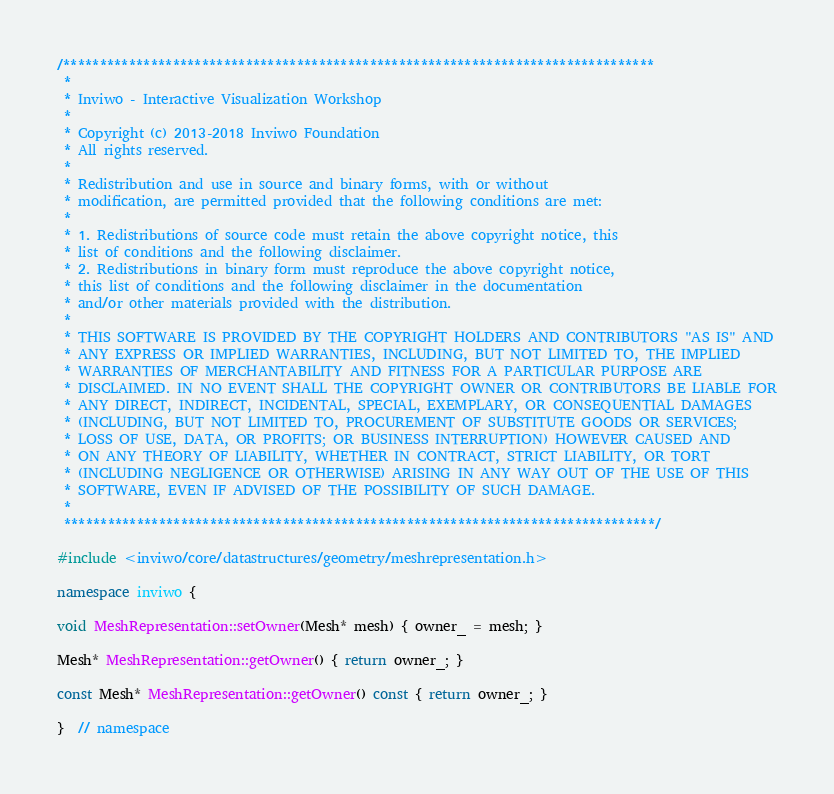<code> <loc_0><loc_0><loc_500><loc_500><_C++_>/*********************************************************************************
 *
 * Inviwo - Interactive Visualization Workshop
 *
 * Copyright (c) 2013-2018 Inviwo Foundation
 * All rights reserved.
 *
 * Redistribution and use in source and binary forms, with or without
 * modification, are permitted provided that the following conditions are met:
 *
 * 1. Redistributions of source code must retain the above copyright notice, this
 * list of conditions and the following disclaimer.
 * 2. Redistributions in binary form must reproduce the above copyright notice,
 * this list of conditions and the following disclaimer in the documentation
 * and/or other materials provided with the distribution.
 *
 * THIS SOFTWARE IS PROVIDED BY THE COPYRIGHT HOLDERS AND CONTRIBUTORS "AS IS" AND
 * ANY EXPRESS OR IMPLIED WARRANTIES, INCLUDING, BUT NOT LIMITED TO, THE IMPLIED
 * WARRANTIES OF MERCHANTABILITY AND FITNESS FOR A PARTICULAR PURPOSE ARE
 * DISCLAIMED. IN NO EVENT SHALL THE COPYRIGHT OWNER OR CONTRIBUTORS BE LIABLE FOR
 * ANY DIRECT, INDIRECT, INCIDENTAL, SPECIAL, EXEMPLARY, OR CONSEQUENTIAL DAMAGES
 * (INCLUDING, BUT NOT LIMITED TO, PROCUREMENT OF SUBSTITUTE GOODS OR SERVICES;
 * LOSS OF USE, DATA, OR PROFITS; OR BUSINESS INTERRUPTION) HOWEVER CAUSED AND
 * ON ANY THEORY OF LIABILITY, WHETHER IN CONTRACT, STRICT LIABILITY, OR TORT
 * (INCLUDING NEGLIGENCE OR OTHERWISE) ARISING IN ANY WAY OUT OF THE USE OF THIS
 * SOFTWARE, EVEN IF ADVISED OF THE POSSIBILITY OF SUCH DAMAGE.
 *
 *********************************************************************************/

#include <inviwo/core/datastructures/geometry/meshrepresentation.h>

namespace inviwo {

void MeshRepresentation::setOwner(Mesh* mesh) { owner_ = mesh; }

Mesh* MeshRepresentation::getOwner() { return owner_; }

const Mesh* MeshRepresentation::getOwner() const { return owner_; }

}  // namespace
</code> 